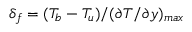Convert formula to latex. <formula><loc_0><loc_0><loc_500><loc_500>\delta _ { f } = ( T _ { b } - T _ { u } ) / ( \partial T / \partial y ) _ { \max }</formula> 